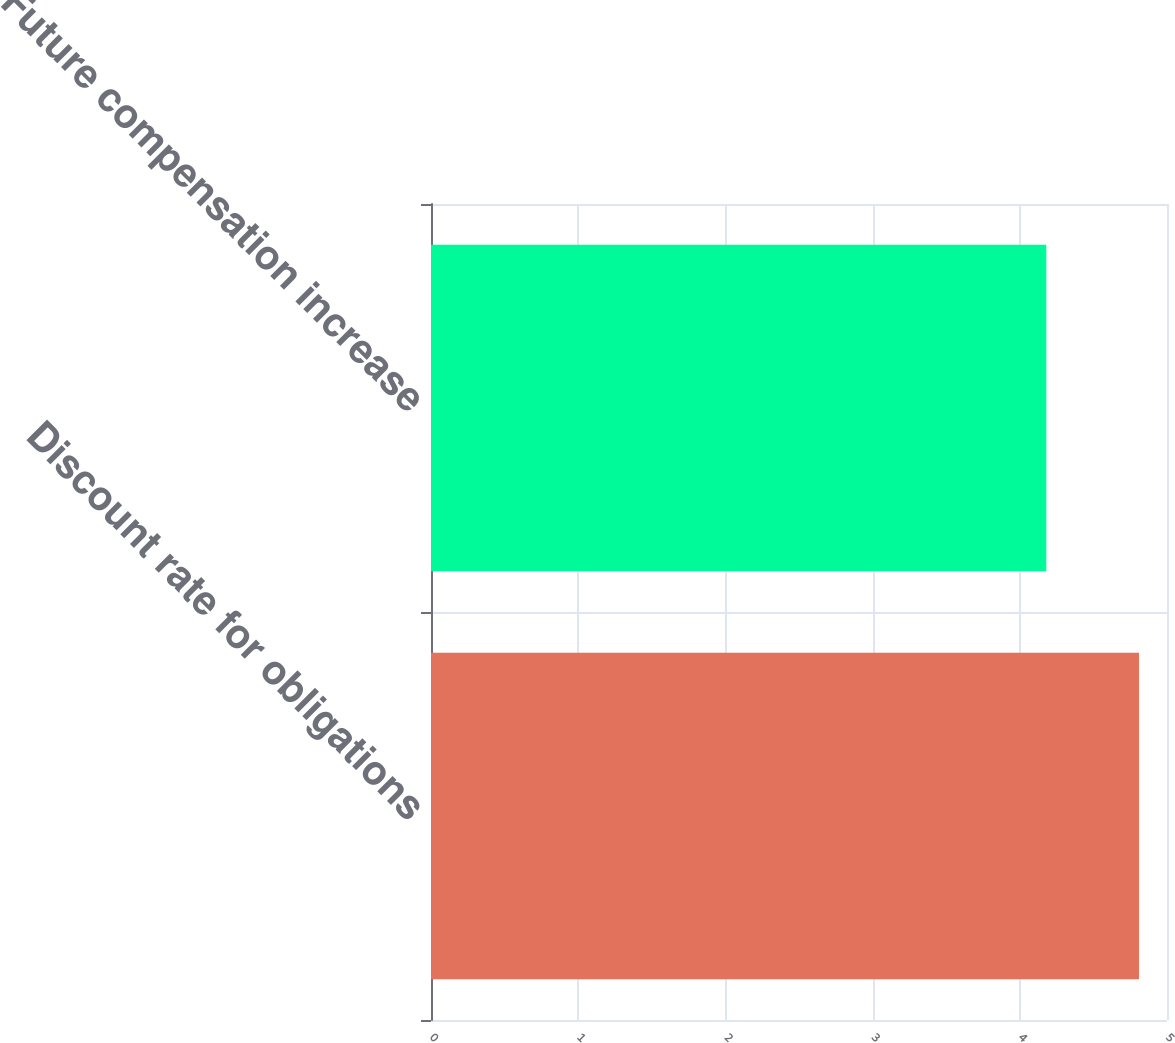Convert chart to OTSL. <chart><loc_0><loc_0><loc_500><loc_500><bar_chart><fcel>Discount rate for obligations<fcel>Future compensation increase<nl><fcel>4.81<fcel>4.18<nl></chart> 